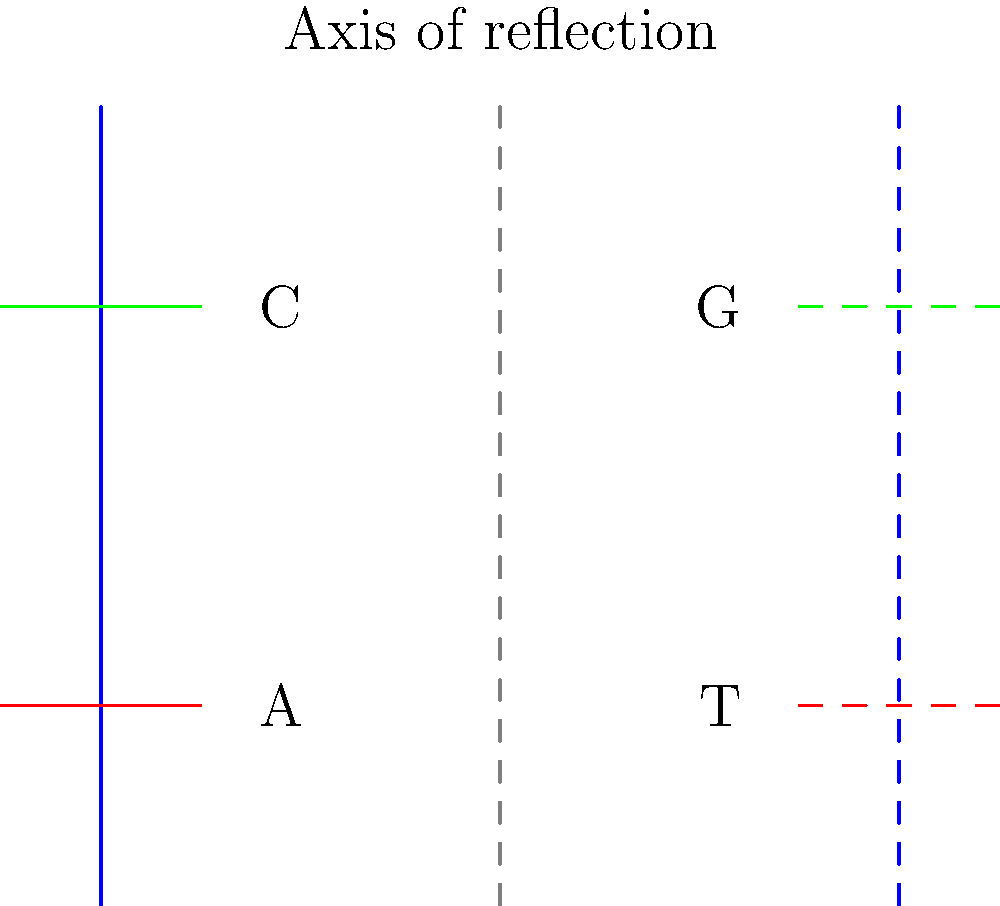In the diagram above, a DNA strand is reflected across the vertical axis. If the original strand has the sequence 5'-AC-3' (reading from bottom to top), what is the complementary sequence of the reflected strand? To solve this problem, we need to follow these steps:

1. Understand DNA base pairing:
   - Adenine (A) pairs with Thymine (T)
   - Cytosine (C) pairs with Guanine (G)

2. Identify the original sequence:
   - The original strand is on the left side
   - Reading from bottom to top, we see A (red) and C (green)
   - So the original sequence is 5'-AC-3'

3. Reflect the sequence:
   - The reflection is shown on the right side of the axis
   - The order of bases is maintained (bottom to top)

4. Determine the complementary sequence:
   - For A, the complement is T
   - For C, the complement is G

5. Write the complementary sequence:
   - Reading from bottom to top on the reflected strand
   - We get 5'-TG-3'

6. Adjust for 5' to 3' direction:
   - DNA strands are antiparallel
   - The complementary strand should be read in the opposite direction
   - So we reverse the order: 3'-GT-5'

Therefore, the complementary sequence of the reflected strand is 3'-GT-5'.
Answer: 3'-GT-5' 